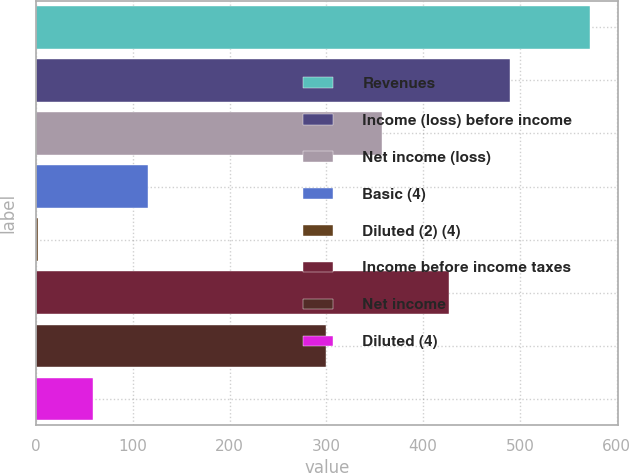Convert chart. <chart><loc_0><loc_0><loc_500><loc_500><bar_chart><fcel>Revenues<fcel>Income (loss) before income<fcel>Net income (loss)<fcel>Basic (4)<fcel>Diluted (2) (4)<fcel>Income before income taxes<fcel>Net income<fcel>Diluted (4)<nl><fcel>573<fcel>490<fcel>357.13<fcel>115.98<fcel>1.72<fcel>427<fcel>300<fcel>58.85<nl></chart> 